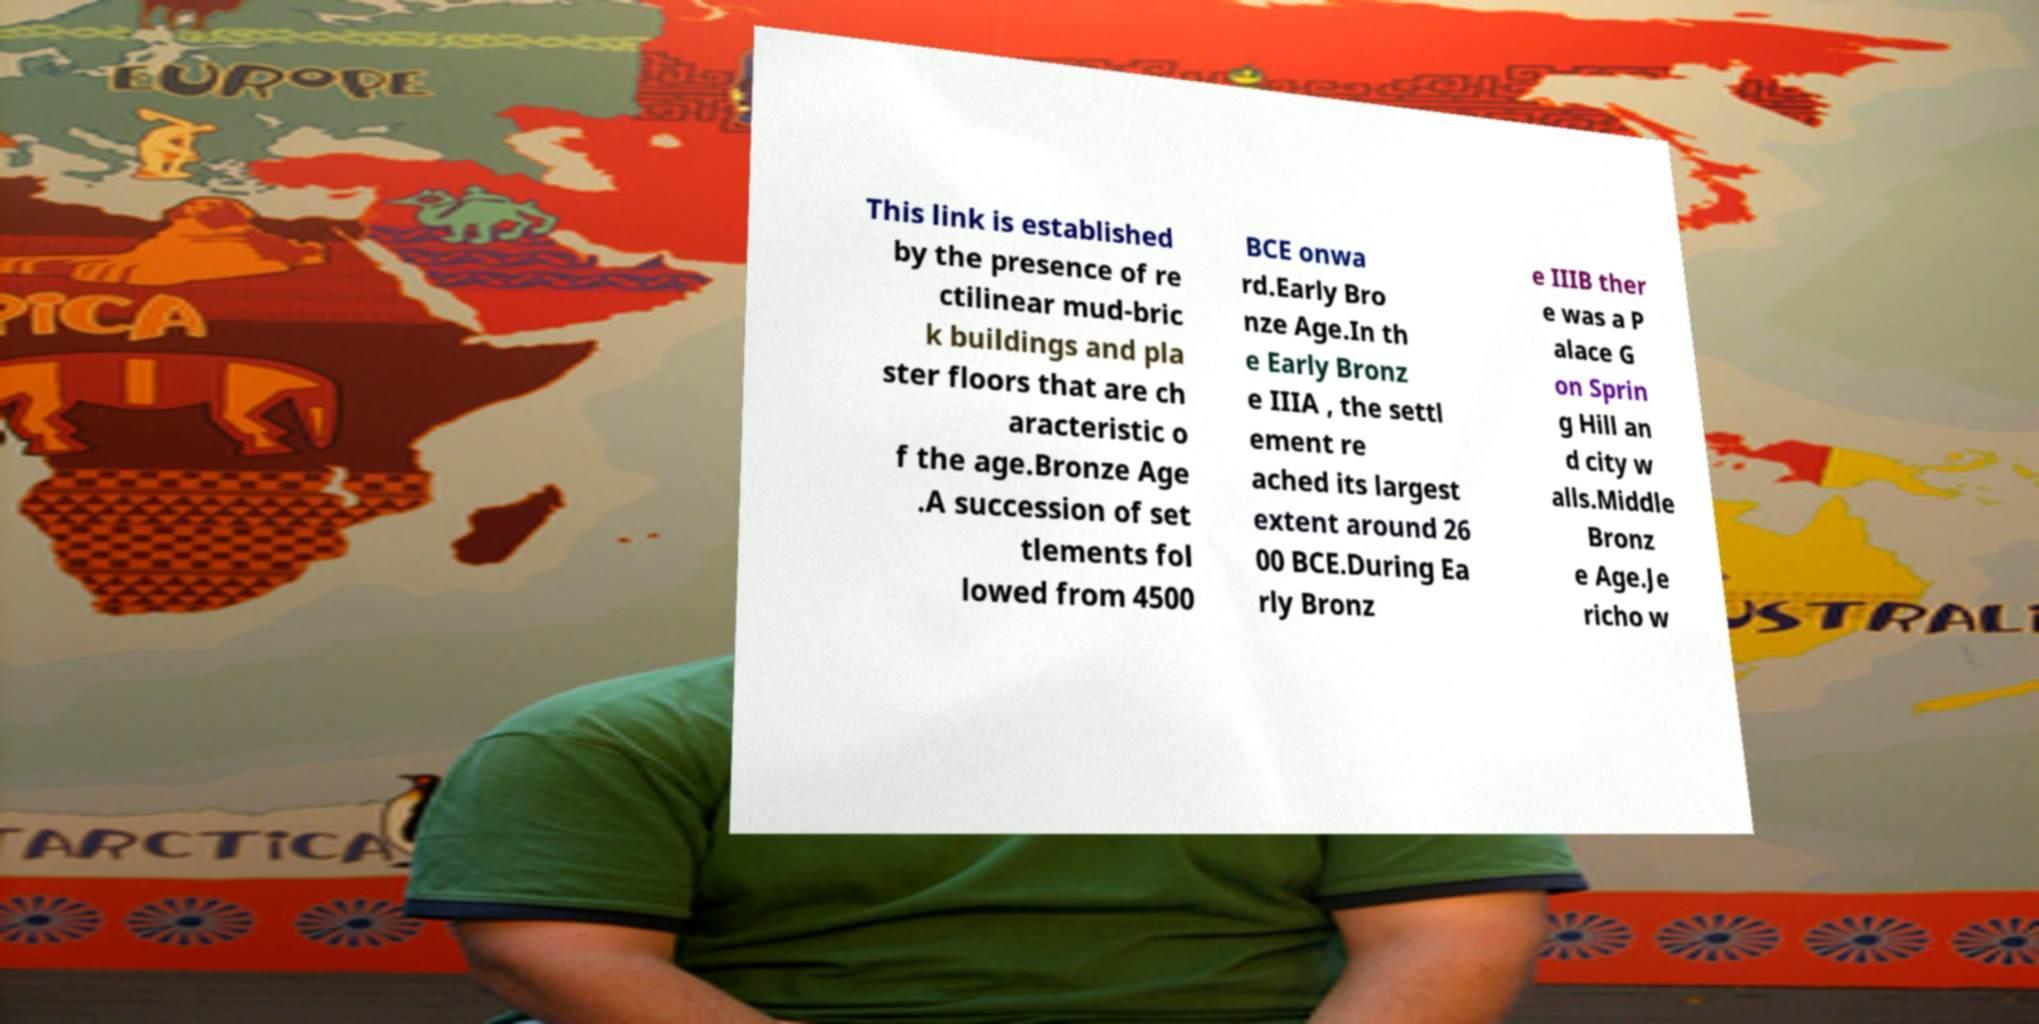Can you read and provide the text displayed in the image?This photo seems to have some interesting text. Can you extract and type it out for me? This link is established by the presence of re ctilinear mud-bric k buildings and pla ster floors that are ch aracteristic o f the age.Bronze Age .A succession of set tlements fol lowed from 4500 BCE onwa rd.Early Bro nze Age.In th e Early Bronz e IIIA , the settl ement re ached its largest extent around 26 00 BCE.During Ea rly Bronz e IIIB ther e was a P alace G on Sprin g Hill an d city w alls.Middle Bronz e Age.Je richo w 